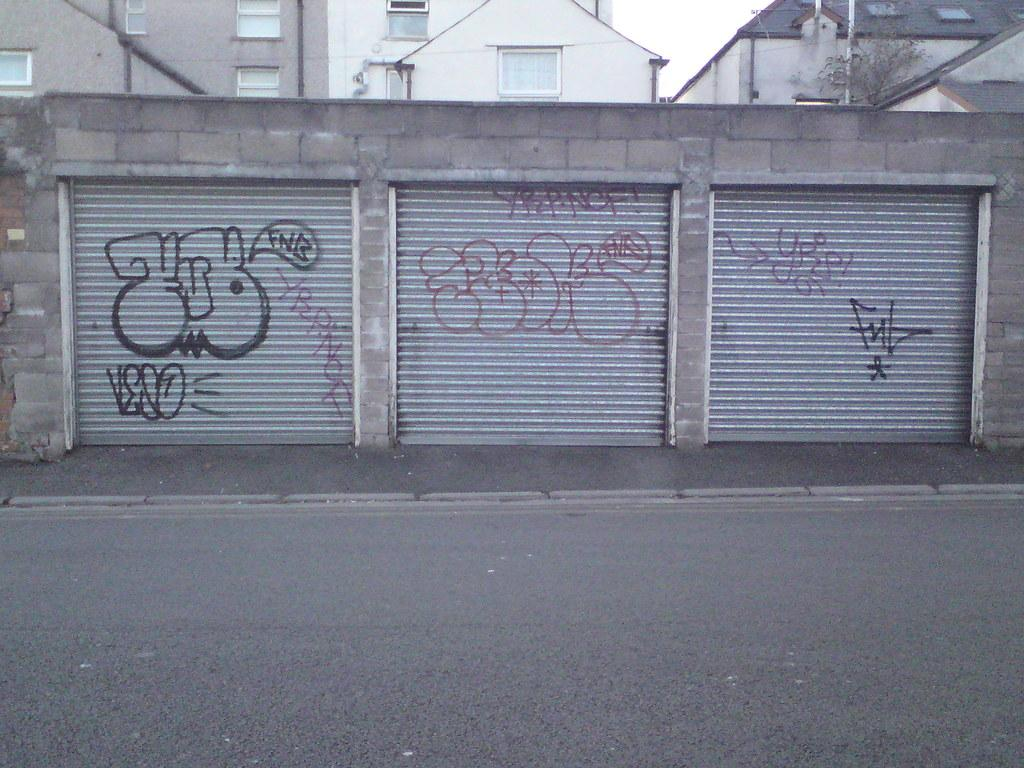What type of window covering is present in the image? There are shutters in the image. What can be seen in the foreground of the image? There is a road in the image. What is visible in the background of the image? There are buildings in the background of the image. What type of vegetation is present in the image? There is a plant in the image. What object is located on the right side of the image? There is a rod on the right side of the image. Can you see a bee buzzing around the plant in the image? There is no bee present in the image; it only features a plant. What type of brick is used to construct the buildings in the image? The image does not provide information about the type of brick used in the construction of the buildings. 